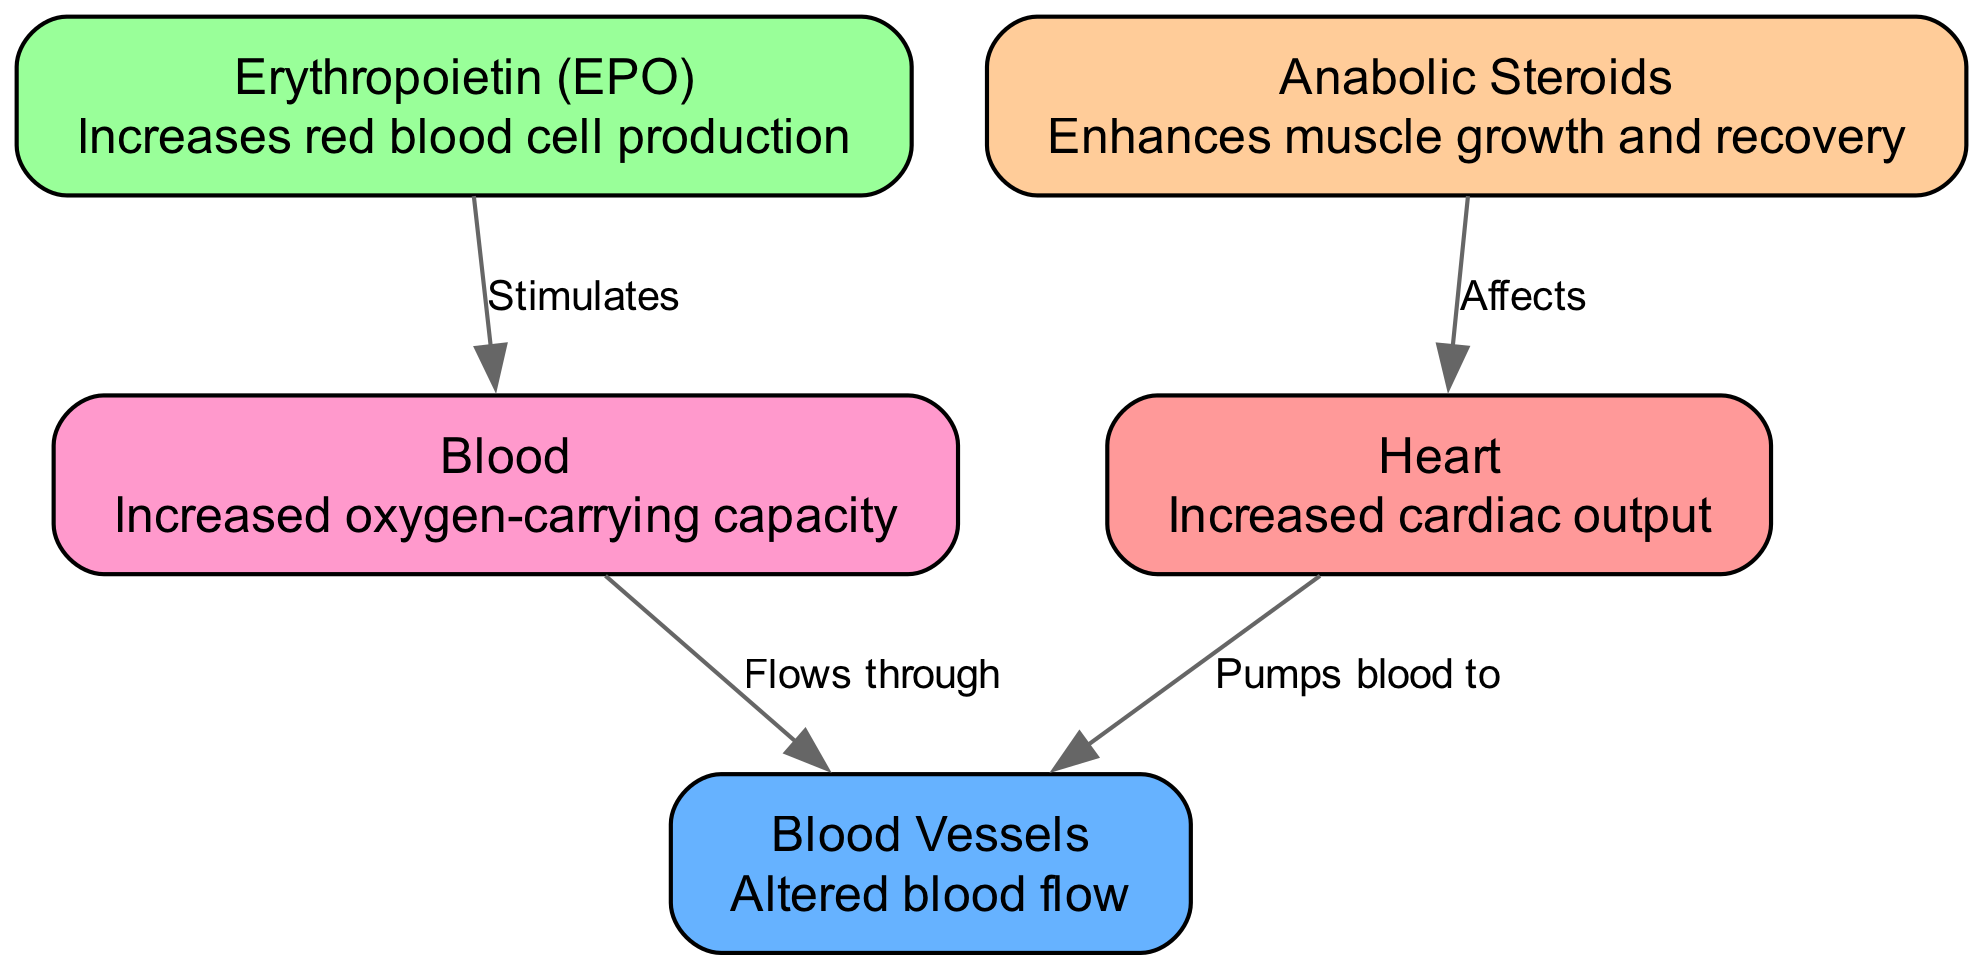What is the role of Erythropoietin (EPO) in the diagram? The diagram indicates that Erythropoietin (EPO) stimulates increased red blood cell production, which enhances the oxygen-carrying capacity of blood.
Answer: Increases red blood cell production How many nodes are present in the diagram? The diagram contains five nodes: Heart, Blood Vessels, Erythropoietin (EPO), Anabolic Steroids, and Blood. Counting them gives a total of five.
Answer: 5 What effect do anabolic steroids have on the heart? The diagram shows that anabolic steroids affect the heart by enhancing muscle growth and recovery, leading to increased cardiac output.
Answer: Affects How does blood flow through the blood vessels? According to the diagram, blood flows through the blood vessels after being pumped from the heart. This connection indicates the role of blood in delivering oxygen and nutrients throughout the body.
Answer: Flows through What is the connection between blood and erythropoietin? The diagram specifies that erythropoietin stimulates the production of blood, emphasizing its crucial role in enhancing the oxygen-carrying capacity of athletes' blood.
Answer: Stimulates What is the relationship between the heart and blood vessels? The diagram points out that the heart pumps blood to the blood vessels, illustrating how the cardiovascular system functions to circulate blood throughout the body.
Answer: Pumps blood to 